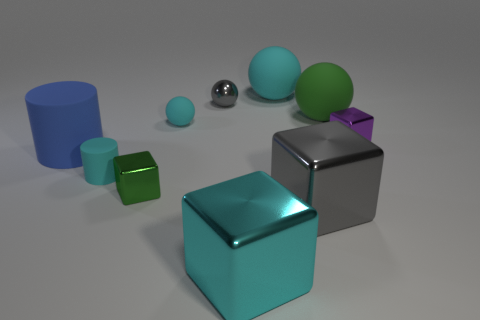Subtract 1 blocks. How many blocks are left? 3 Subtract all blocks. How many objects are left? 6 Add 6 small purple objects. How many small purple objects are left? 7 Add 1 tiny metal objects. How many tiny metal objects exist? 4 Subtract 0 yellow cylinders. How many objects are left? 10 Subtract all blue matte cylinders. Subtract all big cyan matte balls. How many objects are left? 8 